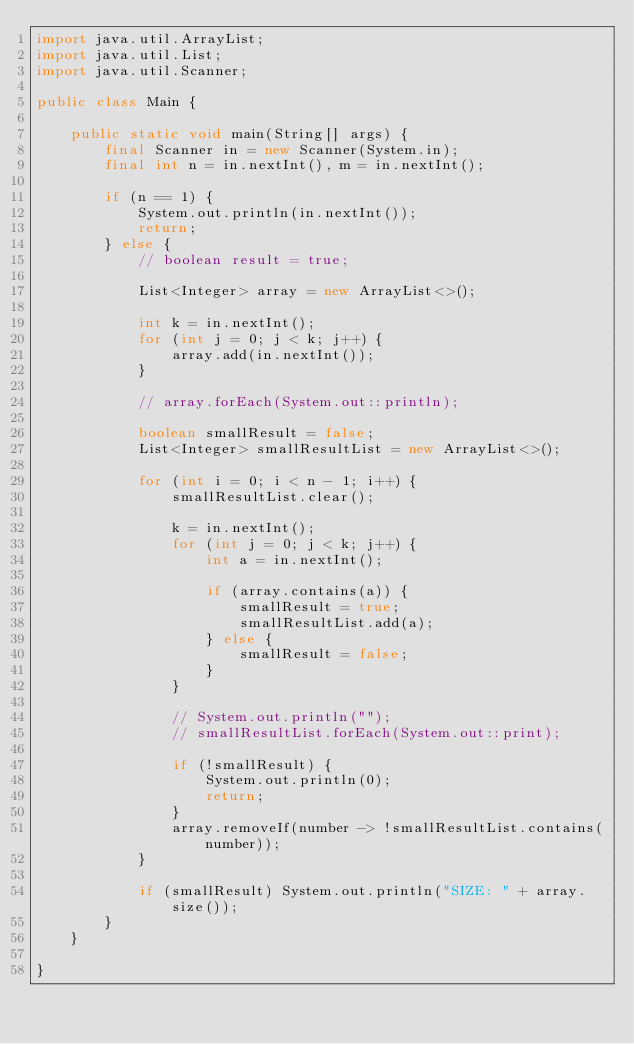<code> <loc_0><loc_0><loc_500><loc_500><_Java_>import java.util.ArrayList;
import java.util.List;
import java.util.Scanner;

public class Main {

	public static void main(String[] args) {
		final Scanner in = new Scanner(System.in);
		final int n = in.nextInt(), m = in.nextInt();

		if (n == 1) {
			System.out.println(in.nextInt());
			return;
		} else {
			// boolean result = true;

			List<Integer> array = new ArrayList<>();

			int k = in.nextInt();
			for (int j = 0; j < k; j++) {
				array.add(in.nextInt());
			}

			// array.forEach(System.out::println);

			boolean smallResult = false;
			List<Integer> smallResultList = new ArrayList<>();

			for (int i = 0; i < n - 1; i++) {
				smallResultList.clear();

				k = in.nextInt();
				for (int j = 0; j < k; j++) {
					int a = in.nextInt();

					if (array.contains(a)) {
						smallResult = true;
						smallResultList.add(a);
					} else {
						smallResult = false;
					}
				}

				// System.out.println("");
				// smallResultList.forEach(System.out::print);

				if (!smallResult) {
					System.out.println(0);
					return;
				}
				array.removeIf(number -> !smallResultList.contains(number));
			}

			if (smallResult) System.out.println("SIZE: " + array.size());
		}
	}

}</code> 